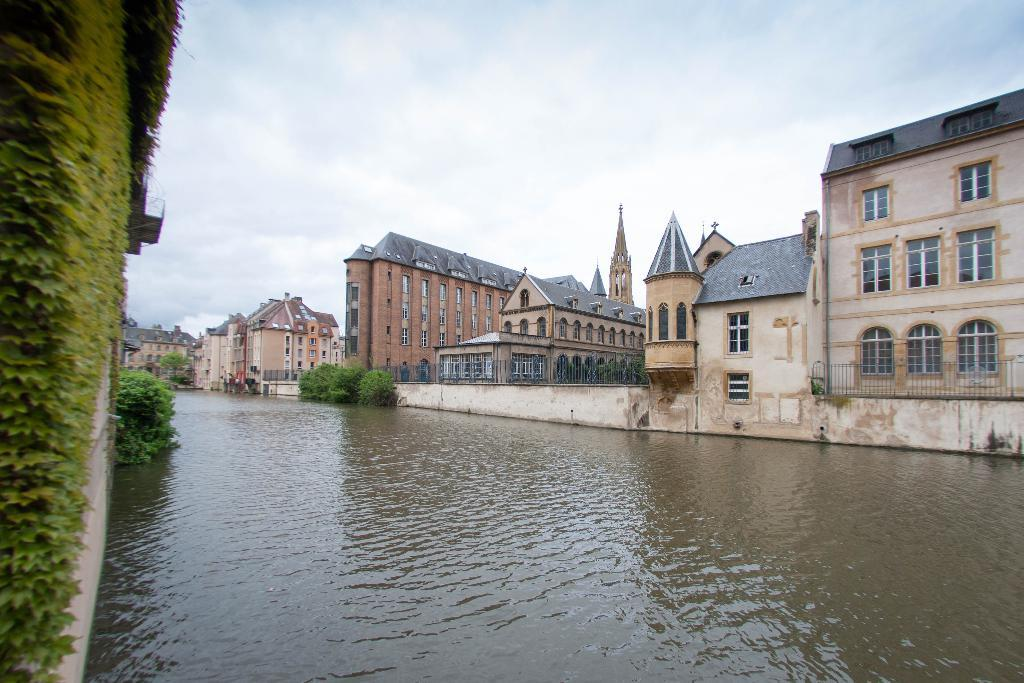What is on the wall in the image? There is a plant on the wall in the image. What else can be seen in the image besides the plant on the wall? There are plants, water, buildings, windows, fences, and clouds in the sky in the background of the image. Can you describe the water in the image? The water is in the middle of the image. What type of vegetation is present in the image? There are plants on the wall, in the image, and in the background of the image. What flavor of camp can be seen in the image? There is no camp present in the image, and therefore no flavor can be determined. 